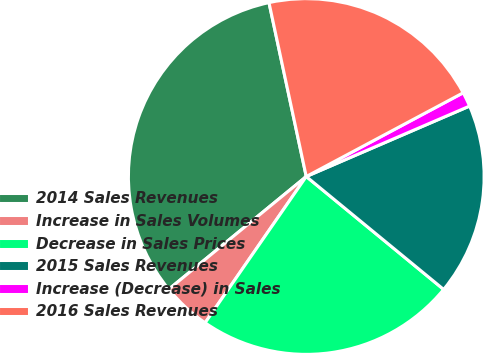<chart> <loc_0><loc_0><loc_500><loc_500><pie_chart><fcel>2014 Sales Revenues<fcel>Increase in Sales Volumes<fcel>Decrease in Sales Prices<fcel>2015 Sales Revenues<fcel>Increase (Decrease) in Sales<fcel>2016 Sales Revenues<nl><fcel>32.57%<fcel>4.44%<fcel>23.68%<fcel>17.43%<fcel>1.32%<fcel>20.56%<nl></chart> 